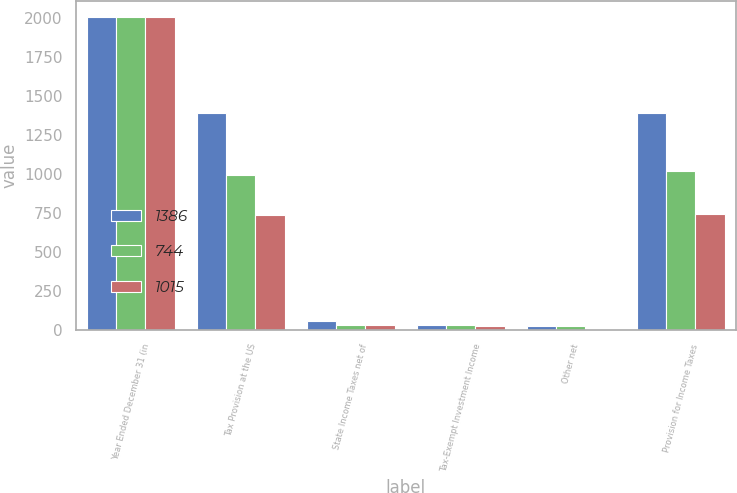Convert chart. <chart><loc_0><loc_0><loc_500><loc_500><stacked_bar_chart><ecel><fcel>Year Ended December 31 (in<fcel>Tax Provision at the US<fcel>State Income Taxes net of<fcel>Tax-Exempt Investment Income<fcel>Other net<fcel>Provision for Income Taxes<nl><fcel>1386<fcel>2004<fcel>1391<fcel>54<fcel>33<fcel>26<fcel>1386<nl><fcel>744<fcel>2003<fcel>994<fcel>29<fcel>30<fcel>22<fcel>1015<nl><fcel>1015<fcel>2002<fcel>734<fcel>33<fcel>26<fcel>3<fcel>744<nl></chart> 